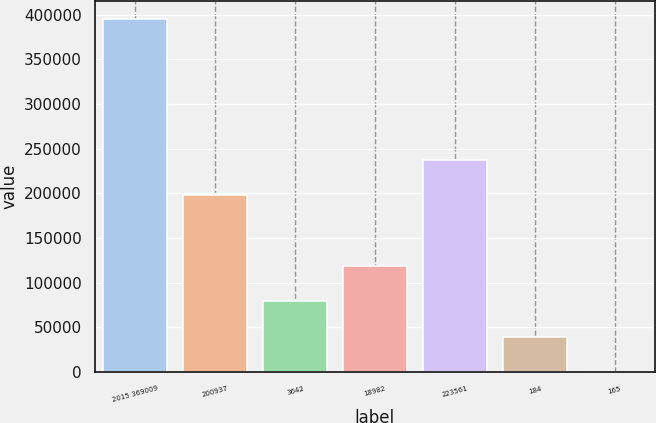Convert chart to OTSL. <chart><loc_0><loc_0><loc_500><loc_500><bar_chart><fcel>2015 369009<fcel>200937<fcel>3642<fcel>18982<fcel>223561<fcel>184<fcel>165<nl><fcel>395281<fcel>198291<fcel>79057.7<fcel>118586<fcel>237819<fcel>39529.7<fcel>1.82<nl></chart> 